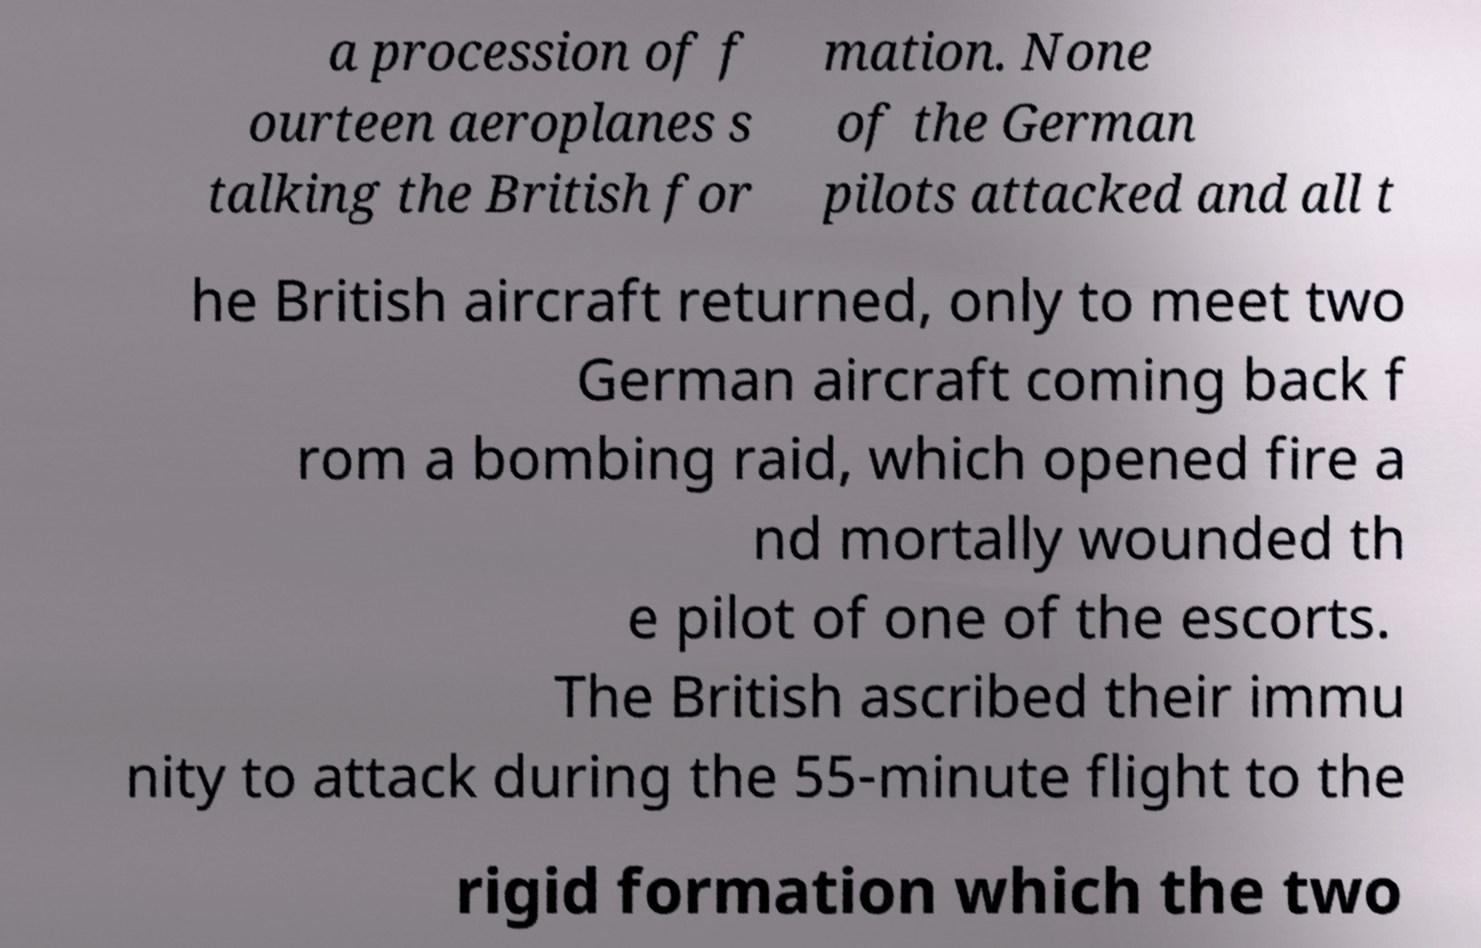Please identify and transcribe the text found in this image. a procession of f ourteen aeroplanes s talking the British for mation. None of the German pilots attacked and all t he British aircraft returned, only to meet two German aircraft coming back f rom a bombing raid, which opened fire a nd mortally wounded th e pilot of one of the escorts. The British ascribed their immu nity to attack during the 55-minute flight to the rigid formation which the two 